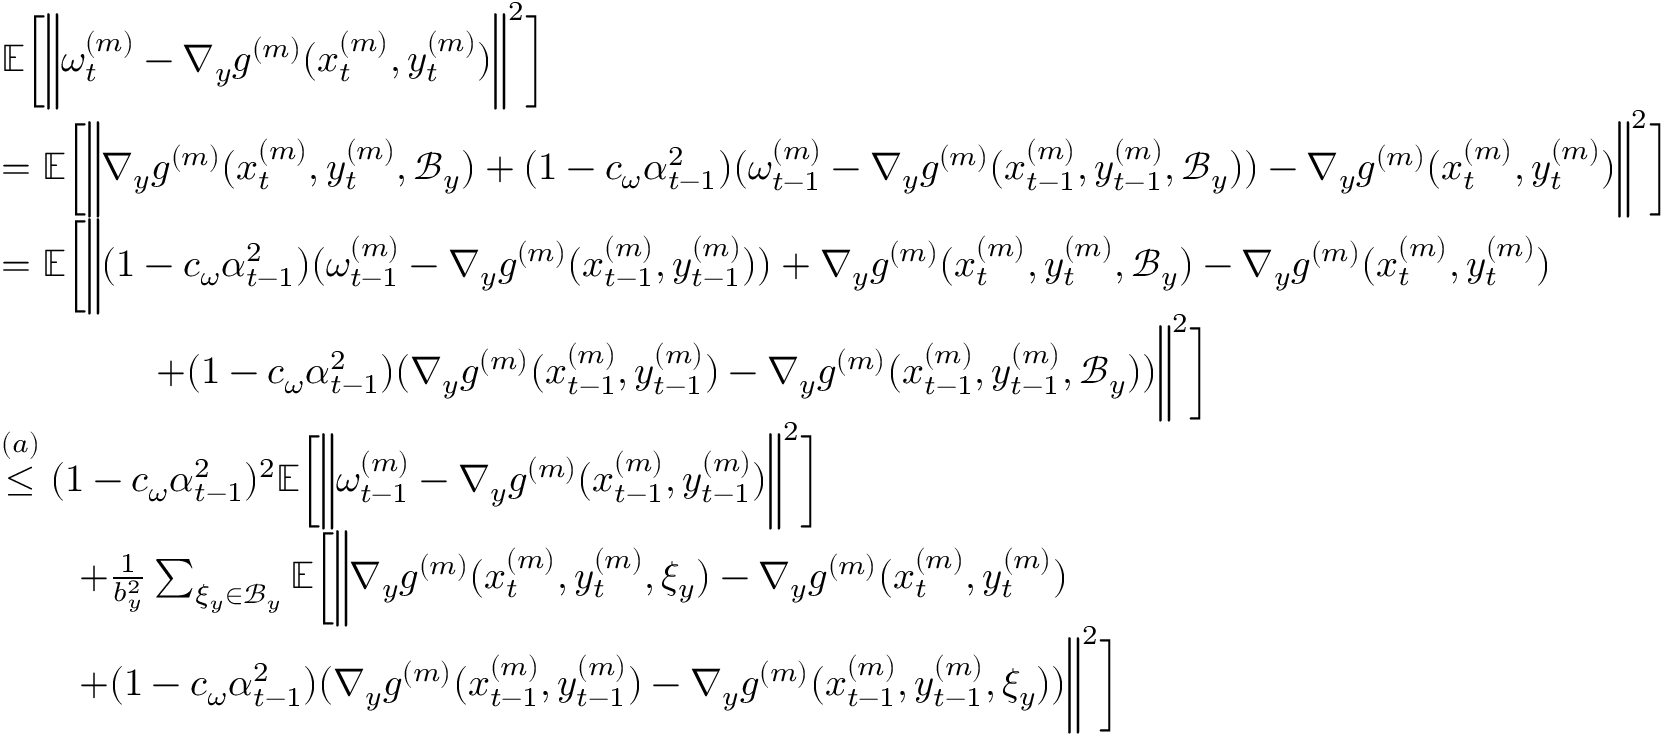Convert formula to latex. <formula><loc_0><loc_0><loc_500><loc_500>\begin{array} { r l } & { \mathbb { E } \left [ \left \| \omega _ { t } ^ { ( m ) } - \nabla _ { y } g ^ { ( m ) } ( x _ { t } ^ { ( m ) } , y _ { t } ^ { ( m ) } ) \right \| ^ { 2 } \right ] } \\ & { = \mathbb { E } \left [ \left \| \nabla _ { y } g ^ { ( m ) } ( x _ { t } ^ { ( m ) } , y _ { t } ^ { ( m ) } , \mathcal { B } _ { y } ) + ( 1 - c _ { \omega } \alpha _ { t - 1 } ^ { 2 } ) ( \omega _ { t - 1 } ^ { ( m ) } - \nabla _ { y } g ^ { ( m ) } ( x _ { t - 1 } ^ { ( m ) } , y _ { t - 1 } ^ { ( m ) } , \mathcal { B } _ { y } ) ) - \nabla _ { y } g ^ { ( m ) } ( x _ { t } ^ { ( m ) } , y _ { t } ^ { ( m ) } ) \right \| ^ { 2 } \right ] } \\ & { = \mathbb { E } \left [ \left \| ( 1 - c _ { \omega } \alpha _ { t - 1 } ^ { 2 } ) ( \omega _ { t - 1 } ^ { ( m ) } - \nabla _ { y } g ^ { ( m ) } ( x _ { t - 1 } ^ { ( m ) } , y _ { t - 1 } ^ { ( m ) } ) ) + \nabla _ { y } g ^ { ( m ) } ( x _ { t } ^ { ( m ) } , y _ { t } ^ { ( m ) } , \mathcal { B } _ { y } ) - \nabla _ { y } g ^ { ( m ) } ( x _ { t } ^ { ( m ) } , y _ { t } ^ { ( m ) } ) } \\ & { \quad + ( 1 - c _ { \omega } \alpha _ { t - 1 } ^ { 2 } ) ( \nabla _ { y } g ^ { ( m ) } ( x _ { t - 1 } ^ { ( m ) } , y _ { t - 1 } ^ { ( m ) } ) - \nabla _ { y } g ^ { ( m ) } ( x _ { t - 1 } ^ { ( m ) } , y _ { t - 1 } ^ { ( m ) } , \mathcal { B } _ { y } ) ) \right \| ^ { 2 } \right ] } \\ & { \overset { ( a ) } { \leq } ( 1 - c _ { \omega } \alpha _ { t - 1 } ^ { 2 } ) ^ { 2 } \mathbb { E } \left [ \left \| \omega _ { t - 1 } ^ { ( m ) } - \nabla _ { y } g ^ { ( m ) } ( x _ { t - 1 } ^ { ( m ) } , y _ { t - 1 } ^ { ( m ) } ) \right \| ^ { 2 } \right ] } \\ & { \quad + \frac { 1 } { b _ { y } ^ { 2 } } \sum _ { \xi _ { y } \in \mathcal { B } _ { y } } \mathbb { E } \left [ \left \| \nabla _ { y } g ^ { ( m ) } ( x _ { t } ^ { ( m ) } , y _ { t } ^ { ( m ) } , \xi _ { y } ) - \nabla _ { y } g ^ { ( m ) } ( x _ { t } ^ { ( m ) } , y _ { t } ^ { ( m ) } ) } \\ & { \quad + ( 1 - c _ { \omega } \alpha _ { t - 1 } ^ { 2 } ) ( \nabla _ { y } g ^ { ( m ) } ( x _ { t - 1 } ^ { ( m ) } , y _ { t - 1 } ^ { ( m ) } ) - \nabla _ { y } g ^ { ( m ) } ( x _ { t - 1 } ^ { ( m ) } , y _ { t - 1 } ^ { ( m ) } , \xi _ { y } ) ) \right \| ^ { 2 } \right ] } \end{array}</formula> 